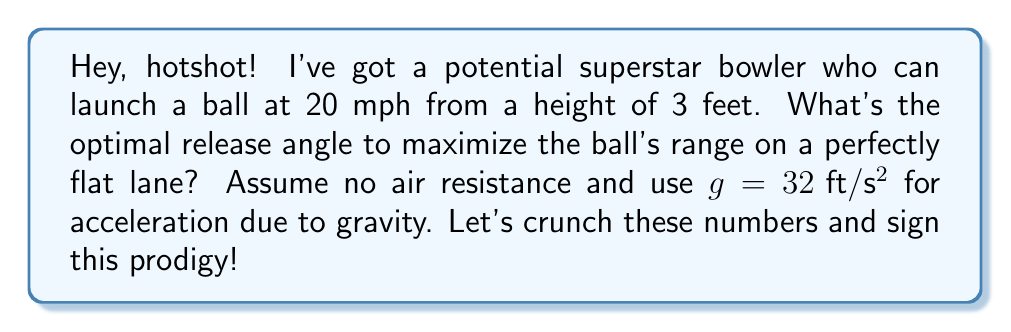Solve this math problem. Let's break this down step-by-step:

1) The range of a projectile on a flat surface is given by the equation:

   $$R = \frac{v^2 \sin(2\theta)}{g}$$

   Where $R$ is the range, $v$ is the initial velocity, $\theta$ is the launch angle, and $g$ is the acceleration due to gravity.

2) We're given:
   - Initial velocity $v = 20 \text{ mph} = 29.33 \text{ ft}/\text{s}$
   - $g = 32 \text{ ft}/\text{s}^2$

3) To maximize the range, we need to maximize $\sin(2\theta)$. The maximum value of sine is 1, which occurs when its argument is 90°.

4) So, $2\theta = 90°$
   $\theta = 45°$

5) We can verify this mathematically:
   $$\frac{d}{d\theta}(\sin(2\theta)) = 2\cos(2\theta)$$
   Setting this to zero:
   $$2\cos(2\theta) = 0$$
   $$\cos(2\theta) = 0$$
   This occurs when $2\theta = 90°$ or $\theta = 45°$

6) The fact that the ball is released from a height of 3 feet doesn't affect the optimal angle. It would affect the total distance traveled, but not the angle that maximizes this distance.

Therefore, the optimal release angle to maximize the ball's range is 45°.
Answer: 45° 